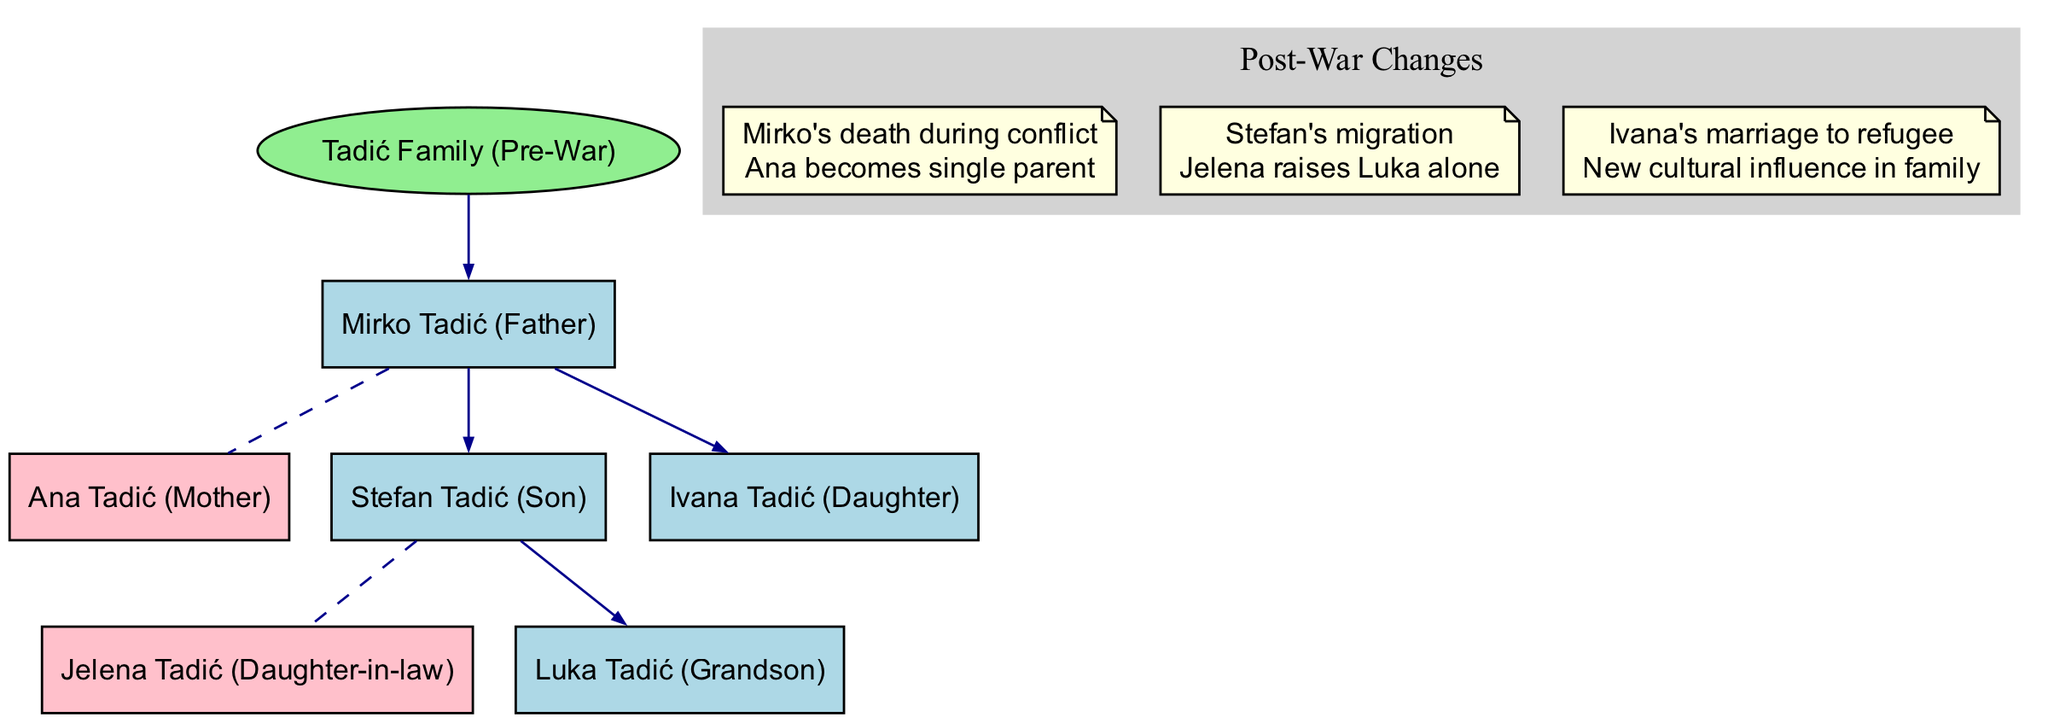What is the name of the root family in the diagram? The root family is clearly labeled as "Tadić Family (Pre-War)" at the top of the diagram. This node represents the starting point of the family tree.
Answer: Tadić Family (Pre-War) How many children does Mirko Tadić have? According to the diagram, Mirko Tadić has two children: Stefan Tadić and Ivana Tadić.
Answer: 2 What happened to Ana Tadić after the conflict? The diagram states under post-war changes that "Ana becomes single parent" after the conflict due to Mirko's death. This indicates a significant change in her family status.
Answer: Single parent Who is raising Luka Tadić? The diagram shows that after Stefan’s migration, Jelena Tadić is raising Luka Tadić alone, as indicated in the event under post-war changes.
Answer: Jelena Tadić What cultural influence is introduced by Ivana Tadić? The diagram indicates that due to Ivana's marriage to a refugee, there is a "New cultural influence in family." This highlights the impact of intercultural relationships following conflict.
Answer: New cultural influence What is the relationship between Ana Tadić and Mirko Tadić? In the family tree, Ana Tadić is connected to Mirko Tadić through a dashed line illustrating marriage, indicating a spousal relationship.
Answer: Married How many total family members are present in the pre-war family structure? Counting all nodes within the pre-war structure: Mirko, Ana, Stefan, Jelena, Luka, and Ivana give us a total of five members, even considering Jelena as the daughter-in-law of Mirko and Ana.
Answer: 5 Which event indicates a significant loss for the family? The event labeled "Mirko's death during conflict" clearly shows a major loss within the family, affecting the entire household structure as reflected in the post-war changes.
Answer: Mirko's death during conflict What is the connection between Ivana Tadić and the refugee? Ivana Tadić is connected to the refugee through marriage, as stated in the post-war changes which describe Ivana's marriage to a refugee, indicating a new familial link.
Answer: Marriage 